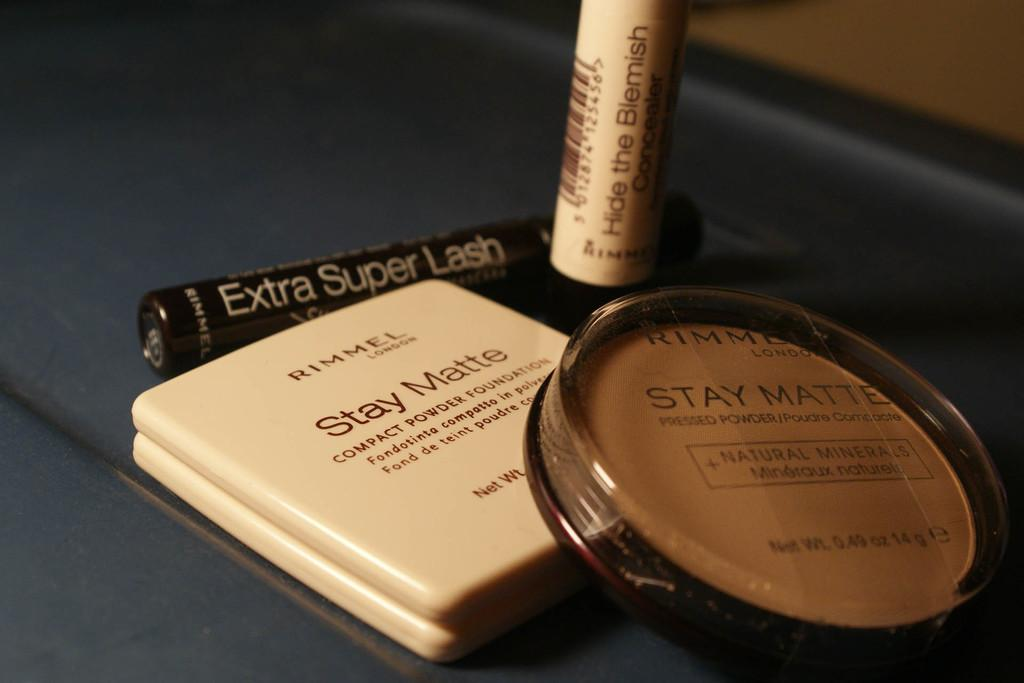Provide a one-sentence caption for the provided image. Some make up items with Stay Matte written on them. 